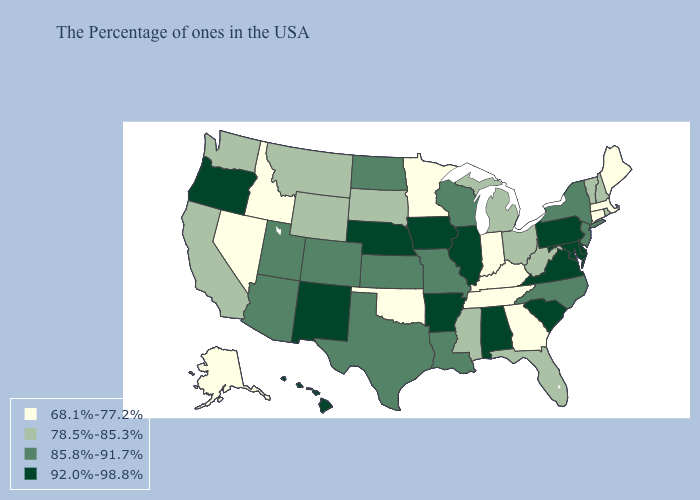What is the value of Missouri?
Concise answer only. 85.8%-91.7%. Does New York have a lower value than Mississippi?
Short answer required. No. Which states have the highest value in the USA?
Answer briefly. Delaware, Maryland, Pennsylvania, Virginia, South Carolina, Alabama, Illinois, Arkansas, Iowa, Nebraska, New Mexico, Oregon, Hawaii. Does the first symbol in the legend represent the smallest category?
Write a very short answer. Yes. Does Nebraska have the highest value in the MidWest?
Be succinct. Yes. What is the value of Maine?
Short answer required. 68.1%-77.2%. Which states have the lowest value in the South?
Concise answer only. Georgia, Kentucky, Tennessee, Oklahoma. Which states have the lowest value in the South?
Be succinct. Georgia, Kentucky, Tennessee, Oklahoma. Does California have a higher value than Oregon?
Give a very brief answer. No. Among the states that border Michigan , which have the highest value?
Short answer required. Wisconsin. Which states have the highest value in the USA?
Answer briefly. Delaware, Maryland, Pennsylvania, Virginia, South Carolina, Alabama, Illinois, Arkansas, Iowa, Nebraska, New Mexico, Oregon, Hawaii. Does the map have missing data?
Give a very brief answer. No. Does the first symbol in the legend represent the smallest category?
Give a very brief answer. Yes. Which states have the lowest value in the USA?
Write a very short answer. Maine, Massachusetts, Connecticut, Georgia, Kentucky, Indiana, Tennessee, Minnesota, Oklahoma, Idaho, Nevada, Alaska. What is the value of South Dakota?
Quick response, please. 78.5%-85.3%. 